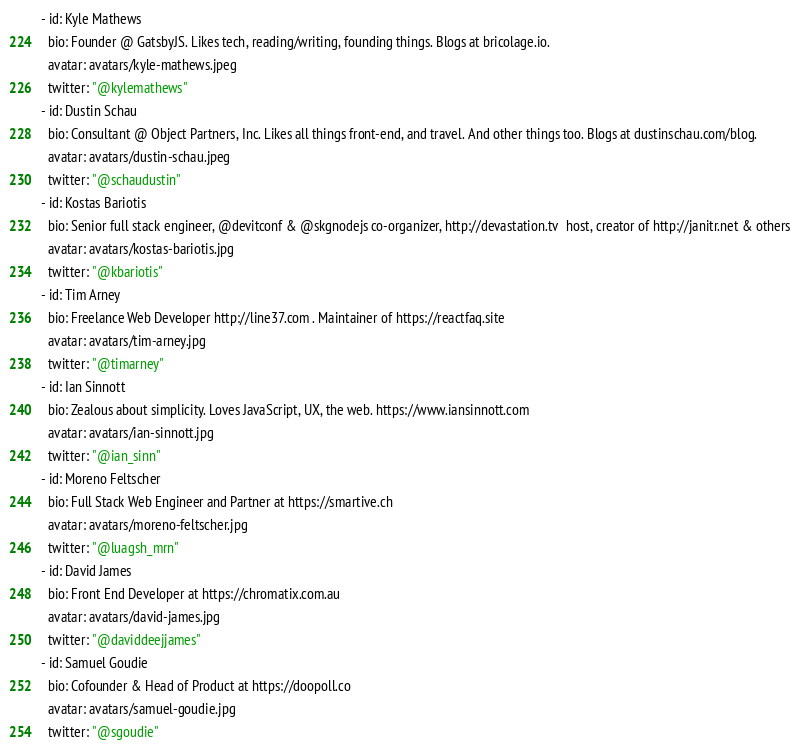<code> <loc_0><loc_0><loc_500><loc_500><_YAML_>- id: Kyle Mathews
  bio: Founder @ GatsbyJS. Likes tech, reading/writing, founding things. Blogs at bricolage.io.
  avatar: avatars/kyle-mathews.jpeg
  twitter: "@kylemathews"
- id: Dustin Schau
  bio: Consultant @ Object Partners, Inc. Likes all things front-end, and travel. And other things too. Blogs at dustinschau.com/blog.
  avatar: avatars/dustin-schau.jpeg
  twitter: "@schaudustin"
- id: Kostas Bariotis
  bio: Senior full stack engineer, @devitconf & @skgnodejs co-organizer, http://devastation.tv  host, creator of http://janitr.net & others
  avatar: avatars/kostas-bariotis.jpg
  twitter: "@kbariotis"
- id: Tim Arney
  bio: Freelance Web Developer http://line37.com . Maintainer of https://reactfaq.site
  avatar: avatars/tim-arney.jpg
  twitter: "@timarney"
- id: Ian Sinnott
  bio: Zealous about simplicity. Loves JavaScript, UX, the web. https://www.iansinnott.com
  avatar: avatars/ian-sinnott.jpg
  twitter: "@ian_sinn"
- id: Moreno Feltscher
  bio: Full Stack Web Engineer and Partner at https://smartive.ch
  avatar: avatars/moreno-feltscher.jpg
  twitter: "@luagsh_mrn"
- id: David James
  bio: Front End Developer at https://chromatix.com.au
  avatar: avatars/david-james.jpg
  twitter: "@daviddeejjames"
- id: Samuel Goudie
  bio: Cofounder & Head of Product at https://doopoll.co
  avatar: avatars/samuel-goudie.jpg
  twitter: "@sgoudie"
</code> 